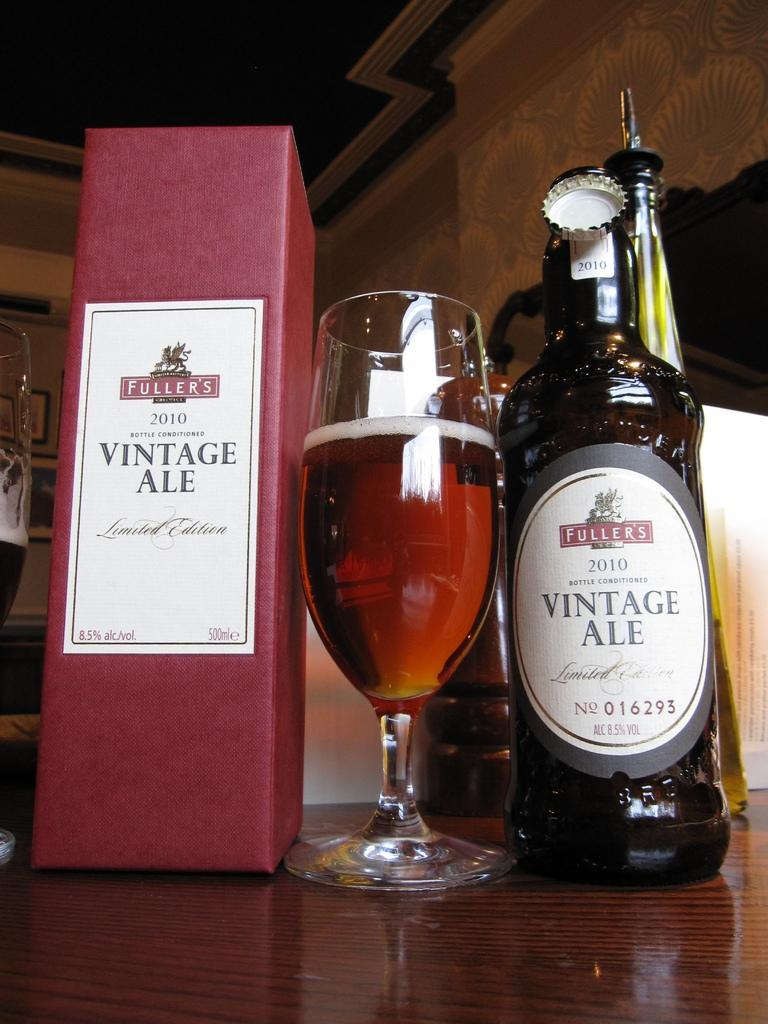<image>
Relay a brief, clear account of the picture shown. the words vintage ale is on a couple bottles 